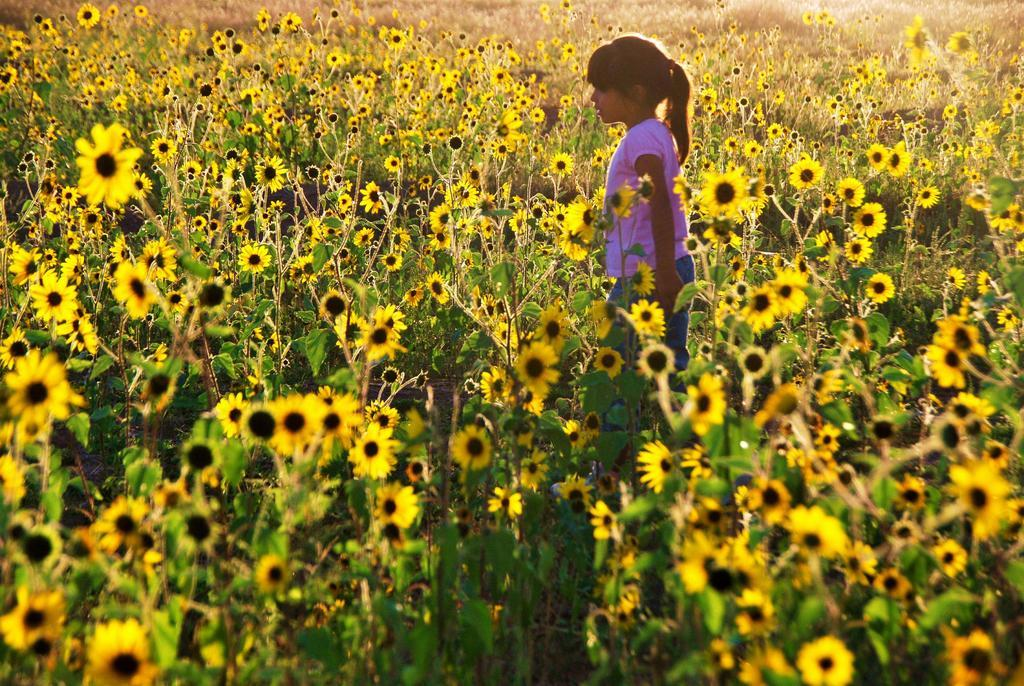Who is the main subject in the image? There is a girl in the image. What is the girl doing in the image? The girl is standing in between sunflowers. What level of expertise does the queen have in sunflower cultivation in the image? There is no queen present in the image, and therefore no information about her expertise in sunflower cultivation can be determined. 